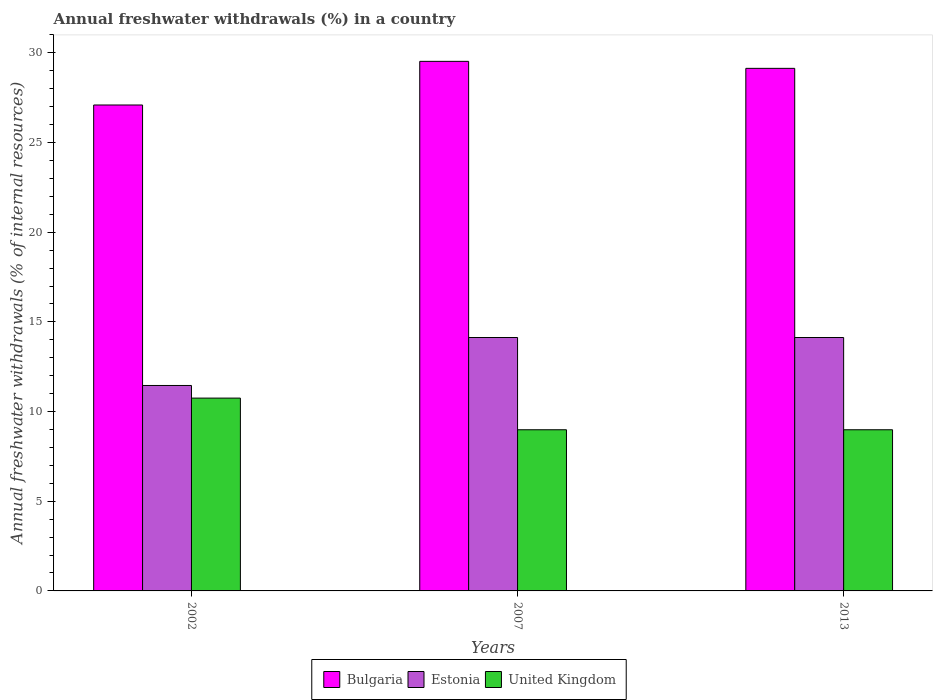How many different coloured bars are there?
Ensure brevity in your answer.  3. Are the number of bars on each tick of the X-axis equal?
Make the answer very short. Yes. How many bars are there on the 2nd tick from the left?
Your answer should be compact. 3. What is the percentage of annual freshwater withdrawals in United Kingdom in 2002?
Your answer should be compact. 10.75. Across all years, what is the maximum percentage of annual freshwater withdrawals in Estonia?
Your answer should be compact. 14.13. Across all years, what is the minimum percentage of annual freshwater withdrawals in Estonia?
Offer a terse response. 11.46. In which year was the percentage of annual freshwater withdrawals in Estonia minimum?
Offer a very short reply. 2002. What is the total percentage of annual freshwater withdrawals in Estonia in the graph?
Give a very brief answer. 39.72. What is the difference between the percentage of annual freshwater withdrawals in Bulgaria in 2002 and that in 2013?
Make the answer very short. -2.04. What is the difference between the percentage of annual freshwater withdrawals in Bulgaria in 2002 and the percentage of annual freshwater withdrawals in Estonia in 2013?
Offer a very short reply. 12.96. What is the average percentage of annual freshwater withdrawals in Estonia per year?
Your answer should be compact. 13.24. In the year 2013, what is the difference between the percentage of annual freshwater withdrawals in Estonia and percentage of annual freshwater withdrawals in Bulgaria?
Provide a succinct answer. -15.01. What is the ratio of the percentage of annual freshwater withdrawals in Estonia in 2002 to that in 2013?
Offer a terse response. 0.81. Is the difference between the percentage of annual freshwater withdrawals in Estonia in 2007 and 2013 greater than the difference between the percentage of annual freshwater withdrawals in Bulgaria in 2007 and 2013?
Provide a short and direct response. No. What is the difference between the highest and the second highest percentage of annual freshwater withdrawals in Estonia?
Give a very brief answer. 0. What is the difference between the highest and the lowest percentage of annual freshwater withdrawals in United Kingdom?
Provide a succinct answer. 1.77. Is the sum of the percentage of annual freshwater withdrawals in United Kingdom in 2007 and 2013 greater than the maximum percentage of annual freshwater withdrawals in Bulgaria across all years?
Your answer should be very brief. No. What does the 2nd bar from the left in 2013 represents?
Your answer should be compact. Estonia. What does the 3rd bar from the right in 2007 represents?
Give a very brief answer. Bulgaria. Is it the case that in every year, the sum of the percentage of annual freshwater withdrawals in Estonia and percentage of annual freshwater withdrawals in United Kingdom is greater than the percentage of annual freshwater withdrawals in Bulgaria?
Ensure brevity in your answer.  No. How many bars are there?
Your answer should be compact. 9. How many years are there in the graph?
Your response must be concise. 3. Are the values on the major ticks of Y-axis written in scientific E-notation?
Give a very brief answer. No. Where does the legend appear in the graph?
Your answer should be compact. Bottom center. What is the title of the graph?
Offer a terse response. Annual freshwater withdrawals (%) in a country. Does "Sint Maarten (Dutch part)" appear as one of the legend labels in the graph?
Give a very brief answer. No. What is the label or title of the Y-axis?
Your response must be concise. Annual freshwater withdrawals (% of internal resources). What is the Annual freshwater withdrawals (% of internal resources) in Bulgaria in 2002?
Give a very brief answer. 27.1. What is the Annual freshwater withdrawals (% of internal resources) in Estonia in 2002?
Ensure brevity in your answer.  11.46. What is the Annual freshwater withdrawals (% of internal resources) in United Kingdom in 2002?
Make the answer very short. 10.75. What is the Annual freshwater withdrawals (% of internal resources) in Bulgaria in 2007?
Your response must be concise. 29.53. What is the Annual freshwater withdrawals (% of internal resources) of Estonia in 2007?
Your answer should be compact. 14.13. What is the Annual freshwater withdrawals (% of internal resources) of United Kingdom in 2007?
Offer a terse response. 8.99. What is the Annual freshwater withdrawals (% of internal resources) of Bulgaria in 2013?
Ensure brevity in your answer.  29.14. What is the Annual freshwater withdrawals (% of internal resources) of Estonia in 2013?
Provide a succinct answer. 14.13. What is the Annual freshwater withdrawals (% of internal resources) of United Kingdom in 2013?
Make the answer very short. 8.99. Across all years, what is the maximum Annual freshwater withdrawals (% of internal resources) of Bulgaria?
Make the answer very short. 29.53. Across all years, what is the maximum Annual freshwater withdrawals (% of internal resources) in Estonia?
Your response must be concise. 14.13. Across all years, what is the maximum Annual freshwater withdrawals (% of internal resources) in United Kingdom?
Keep it short and to the point. 10.75. Across all years, what is the minimum Annual freshwater withdrawals (% of internal resources) of Bulgaria?
Give a very brief answer. 27.1. Across all years, what is the minimum Annual freshwater withdrawals (% of internal resources) in Estonia?
Your answer should be very brief. 11.46. Across all years, what is the minimum Annual freshwater withdrawals (% of internal resources) in United Kingdom?
Provide a short and direct response. 8.99. What is the total Annual freshwater withdrawals (% of internal resources) of Bulgaria in the graph?
Your answer should be compact. 85.76. What is the total Annual freshwater withdrawals (% of internal resources) of Estonia in the graph?
Your answer should be very brief. 39.72. What is the total Annual freshwater withdrawals (% of internal resources) in United Kingdom in the graph?
Your answer should be very brief. 28.72. What is the difference between the Annual freshwater withdrawals (% of internal resources) of Bulgaria in 2002 and that in 2007?
Make the answer very short. -2.43. What is the difference between the Annual freshwater withdrawals (% of internal resources) of Estonia in 2002 and that in 2007?
Offer a very short reply. -2.68. What is the difference between the Annual freshwater withdrawals (% of internal resources) in United Kingdom in 2002 and that in 2007?
Keep it short and to the point. 1.77. What is the difference between the Annual freshwater withdrawals (% of internal resources) in Bulgaria in 2002 and that in 2013?
Offer a terse response. -2.04. What is the difference between the Annual freshwater withdrawals (% of internal resources) of Estonia in 2002 and that in 2013?
Ensure brevity in your answer.  -2.68. What is the difference between the Annual freshwater withdrawals (% of internal resources) of United Kingdom in 2002 and that in 2013?
Offer a very short reply. 1.77. What is the difference between the Annual freshwater withdrawals (% of internal resources) of Bulgaria in 2007 and that in 2013?
Give a very brief answer. 0.39. What is the difference between the Annual freshwater withdrawals (% of internal resources) of Estonia in 2007 and that in 2013?
Give a very brief answer. 0. What is the difference between the Annual freshwater withdrawals (% of internal resources) in United Kingdom in 2007 and that in 2013?
Offer a terse response. 0. What is the difference between the Annual freshwater withdrawals (% of internal resources) of Bulgaria in 2002 and the Annual freshwater withdrawals (% of internal resources) of Estonia in 2007?
Ensure brevity in your answer.  12.96. What is the difference between the Annual freshwater withdrawals (% of internal resources) in Bulgaria in 2002 and the Annual freshwater withdrawals (% of internal resources) in United Kingdom in 2007?
Your response must be concise. 18.11. What is the difference between the Annual freshwater withdrawals (% of internal resources) in Estonia in 2002 and the Annual freshwater withdrawals (% of internal resources) in United Kingdom in 2007?
Ensure brevity in your answer.  2.47. What is the difference between the Annual freshwater withdrawals (% of internal resources) of Bulgaria in 2002 and the Annual freshwater withdrawals (% of internal resources) of Estonia in 2013?
Your answer should be very brief. 12.96. What is the difference between the Annual freshwater withdrawals (% of internal resources) of Bulgaria in 2002 and the Annual freshwater withdrawals (% of internal resources) of United Kingdom in 2013?
Provide a short and direct response. 18.11. What is the difference between the Annual freshwater withdrawals (% of internal resources) in Estonia in 2002 and the Annual freshwater withdrawals (% of internal resources) in United Kingdom in 2013?
Offer a very short reply. 2.47. What is the difference between the Annual freshwater withdrawals (% of internal resources) of Bulgaria in 2007 and the Annual freshwater withdrawals (% of internal resources) of Estonia in 2013?
Your response must be concise. 15.4. What is the difference between the Annual freshwater withdrawals (% of internal resources) in Bulgaria in 2007 and the Annual freshwater withdrawals (% of internal resources) in United Kingdom in 2013?
Give a very brief answer. 20.54. What is the difference between the Annual freshwater withdrawals (% of internal resources) of Estonia in 2007 and the Annual freshwater withdrawals (% of internal resources) of United Kingdom in 2013?
Give a very brief answer. 5.14. What is the average Annual freshwater withdrawals (% of internal resources) of Bulgaria per year?
Give a very brief answer. 28.59. What is the average Annual freshwater withdrawals (% of internal resources) in Estonia per year?
Offer a very short reply. 13.24. What is the average Annual freshwater withdrawals (% of internal resources) of United Kingdom per year?
Make the answer very short. 9.57. In the year 2002, what is the difference between the Annual freshwater withdrawals (% of internal resources) in Bulgaria and Annual freshwater withdrawals (% of internal resources) in Estonia?
Your answer should be compact. 15.64. In the year 2002, what is the difference between the Annual freshwater withdrawals (% of internal resources) of Bulgaria and Annual freshwater withdrawals (% of internal resources) of United Kingdom?
Your response must be concise. 16.34. In the year 2002, what is the difference between the Annual freshwater withdrawals (% of internal resources) of Estonia and Annual freshwater withdrawals (% of internal resources) of United Kingdom?
Offer a terse response. 0.7. In the year 2007, what is the difference between the Annual freshwater withdrawals (% of internal resources) of Bulgaria and Annual freshwater withdrawals (% of internal resources) of Estonia?
Your answer should be very brief. 15.4. In the year 2007, what is the difference between the Annual freshwater withdrawals (% of internal resources) in Bulgaria and Annual freshwater withdrawals (% of internal resources) in United Kingdom?
Your answer should be very brief. 20.54. In the year 2007, what is the difference between the Annual freshwater withdrawals (% of internal resources) of Estonia and Annual freshwater withdrawals (% of internal resources) of United Kingdom?
Your response must be concise. 5.14. In the year 2013, what is the difference between the Annual freshwater withdrawals (% of internal resources) in Bulgaria and Annual freshwater withdrawals (% of internal resources) in Estonia?
Offer a very short reply. 15.01. In the year 2013, what is the difference between the Annual freshwater withdrawals (% of internal resources) in Bulgaria and Annual freshwater withdrawals (% of internal resources) in United Kingdom?
Your answer should be very brief. 20.15. In the year 2013, what is the difference between the Annual freshwater withdrawals (% of internal resources) in Estonia and Annual freshwater withdrawals (% of internal resources) in United Kingdom?
Give a very brief answer. 5.14. What is the ratio of the Annual freshwater withdrawals (% of internal resources) of Bulgaria in 2002 to that in 2007?
Provide a succinct answer. 0.92. What is the ratio of the Annual freshwater withdrawals (% of internal resources) in Estonia in 2002 to that in 2007?
Provide a short and direct response. 0.81. What is the ratio of the Annual freshwater withdrawals (% of internal resources) of United Kingdom in 2002 to that in 2007?
Provide a succinct answer. 1.2. What is the ratio of the Annual freshwater withdrawals (% of internal resources) of Bulgaria in 2002 to that in 2013?
Ensure brevity in your answer.  0.93. What is the ratio of the Annual freshwater withdrawals (% of internal resources) in Estonia in 2002 to that in 2013?
Offer a very short reply. 0.81. What is the ratio of the Annual freshwater withdrawals (% of internal resources) in United Kingdom in 2002 to that in 2013?
Offer a very short reply. 1.2. What is the ratio of the Annual freshwater withdrawals (% of internal resources) of Bulgaria in 2007 to that in 2013?
Give a very brief answer. 1.01. What is the difference between the highest and the second highest Annual freshwater withdrawals (% of internal resources) of Bulgaria?
Your answer should be very brief. 0.39. What is the difference between the highest and the second highest Annual freshwater withdrawals (% of internal resources) of United Kingdom?
Make the answer very short. 1.77. What is the difference between the highest and the lowest Annual freshwater withdrawals (% of internal resources) in Bulgaria?
Your response must be concise. 2.43. What is the difference between the highest and the lowest Annual freshwater withdrawals (% of internal resources) of Estonia?
Give a very brief answer. 2.68. What is the difference between the highest and the lowest Annual freshwater withdrawals (% of internal resources) in United Kingdom?
Provide a succinct answer. 1.77. 